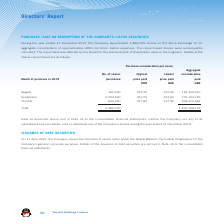According to Tencent's financial document, How many shares did the Company repurchase during the year ended 31 December 2019? According to the financial document, 3,486,700. The relevant text states: "r ended 31 December 2019, the Company repurchased 3,486,700 shares on the Stock Exchange for an..." Also, How much did the Company pay for the repurchased shares?  According to the financial document, HKD1.16 billion. The relevant text states: "aggregate consideration of approximately HKD1.16 billion before expenses. The repurchased shares were subsequently..." Also, How many shares was purchased in August? According to the financial document, 362,200. The relevant text states: "August 362,200 327.00 312.40 116,330,916..." Also, can you calculate: What percentage of total shares purchased is the August share purchase? Based on the calculation: 362,200/3,486,700, the result is 10.39 (percentage). This is based on the information: "August 362,200 327.00 312.40 116,330,916 Total: 3,486,700 1,160,708,107..." The key data points involved are: 3,486,700, 362,200. Also, can you calculate: What percentage of total shares purchased is the September share purchase? Based on the calculation: 2,294,500/3,486,700, the result is 65.81 (percentage). This is based on the information: "September 2,294,500 351.00 323.60 776,104,729 Total: 3,486,700 1,160,708,107..." The key data points involved are: 2,294,500, 3,486,700. Also, can you calculate: What percentage of the total aggregate consideration paid is the August aggregate consideration paid? Based on the calculation: 116,330,916/1,160,708,107, the result is 10.02 (percentage). This is based on the information: "August 362,200 327.00 312.40 116,330,916 Total: 3,486,700 1,160,708,107..." The key data points involved are: 1,160,708,107, 116,330,916. 